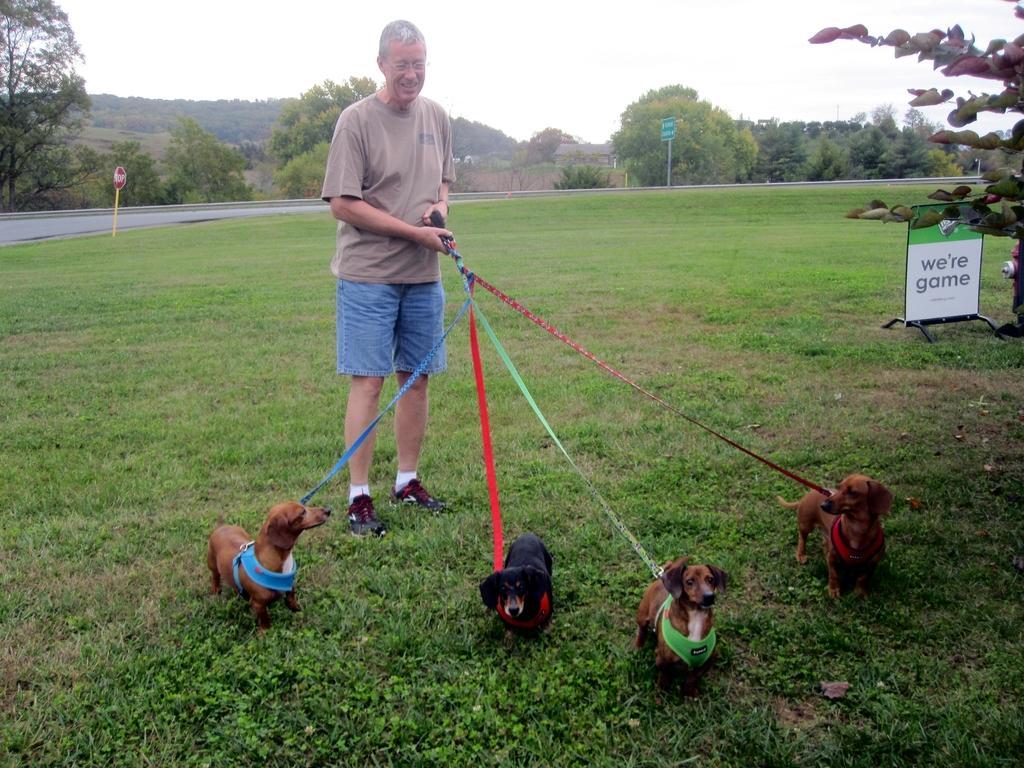Can you describe this image briefly? In this image there is a person standing on the grass and holding the belts of four dogs which are on the grass , and in the background there are sign boards attached to the poles, plants, trees, house, hills, sky. 